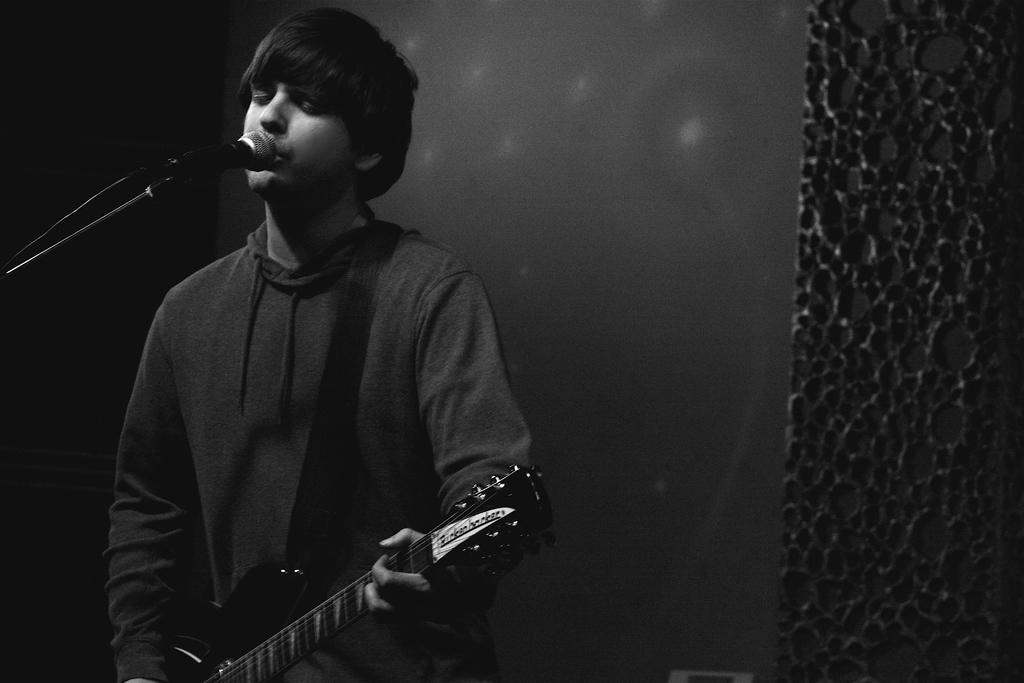What is the main subject of the image? The main subject of the image is a man. What is the man holding in his hand? The man is holding a guitar in his hand. What is the color scheme of the image? The image is in black and white color. What type of education is the man pursuing in the image? There is no indication of the man pursuing any education in the image. Is the man a spy in the image? There is no indication of the man being a spy in the image. 